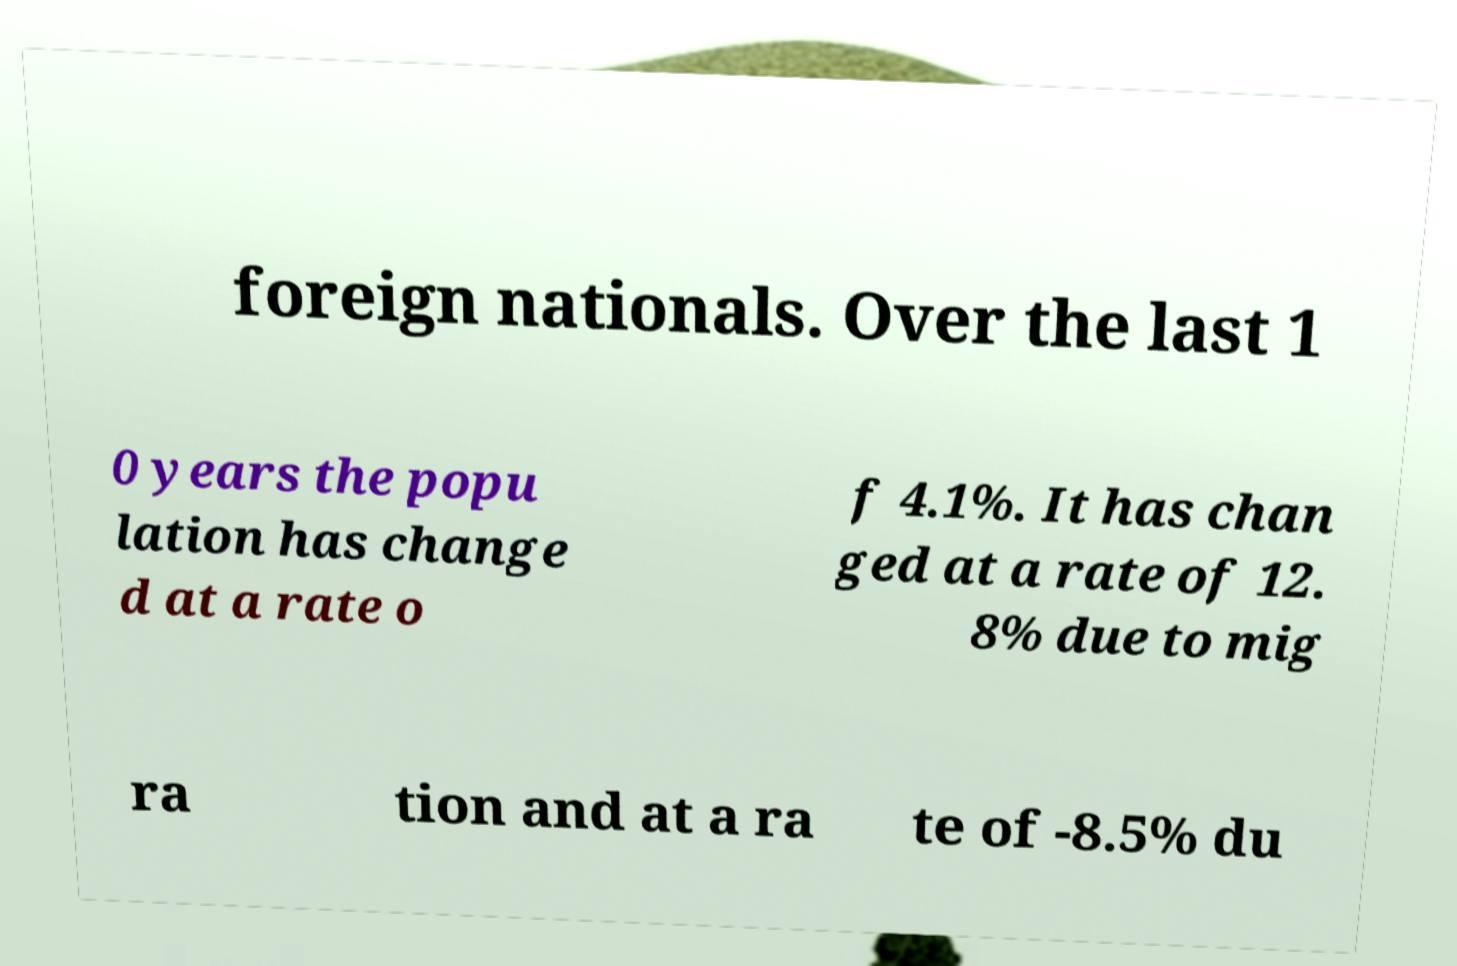There's text embedded in this image that I need extracted. Can you transcribe it verbatim? foreign nationals. Over the last 1 0 years the popu lation has change d at a rate o f 4.1%. It has chan ged at a rate of 12. 8% due to mig ra tion and at a ra te of -8.5% du 